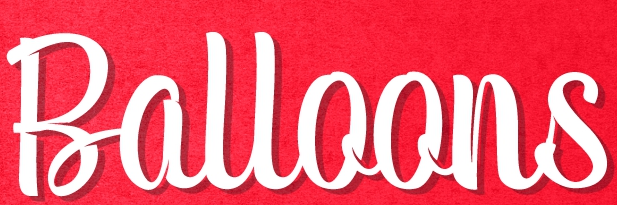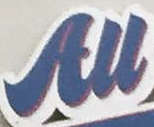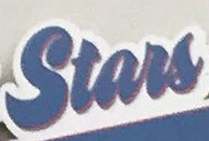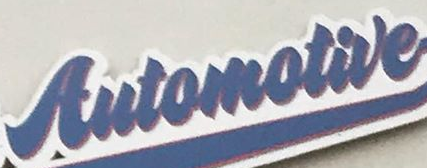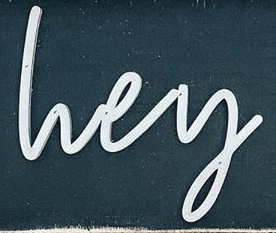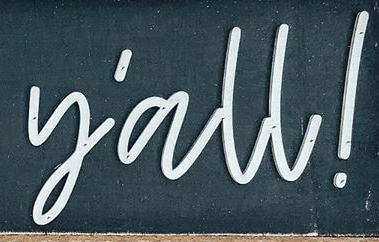What text appears in these images from left to right, separated by a semicolon? Balloons; All; Stars; Automotive; lvey; y'all! 